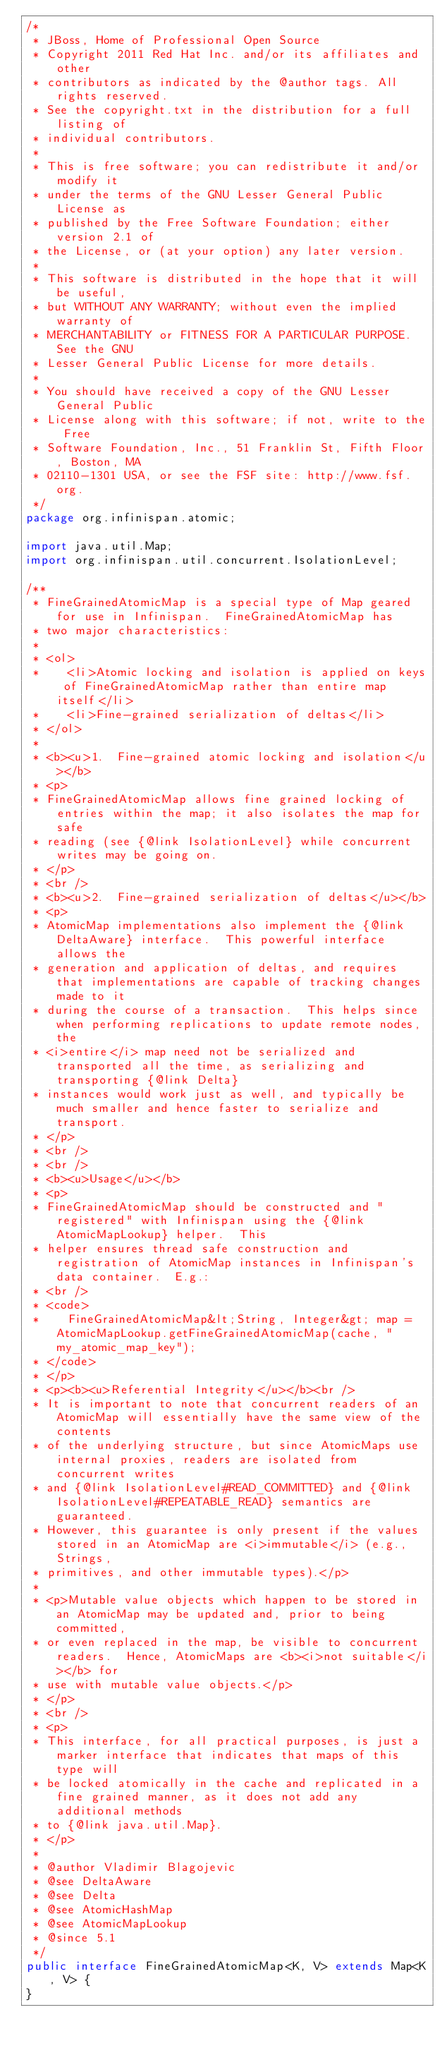<code> <loc_0><loc_0><loc_500><loc_500><_Java_>/*
 * JBoss, Home of Professional Open Source
 * Copyright 2011 Red Hat Inc. and/or its affiliates and other
 * contributors as indicated by the @author tags. All rights reserved.
 * See the copyright.txt in the distribution for a full listing of
 * individual contributors.
 *
 * This is free software; you can redistribute it and/or modify it
 * under the terms of the GNU Lesser General Public License as
 * published by the Free Software Foundation; either version 2.1 of
 * the License, or (at your option) any later version.
 *
 * This software is distributed in the hope that it will be useful,
 * but WITHOUT ANY WARRANTY; without even the implied warranty of
 * MERCHANTABILITY or FITNESS FOR A PARTICULAR PURPOSE. See the GNU
 * Lesser General Public License for more details.
 *
 * You should have received a copy of the GNU Lesser General Public
 * License along with this software; if not, write to the Free
 * Software Foundation, Inc., 51 Franklin St, Fifth Floor, Boston, MA
 * 02110-1301 USA, or see the FSF site: http://www.fsf.org.
 */
package org.infinispan.atomic;

import java.util.Map;
import org.infinispan.util.concurrent.IsolationLevel;

/**
 * FineGrainedAtomicMap is a special type of Map geared for use in Infinispan.  FineGrainedAtomicMap has 
 * two major characteristics:
 *
 * <ol>
 *    <li>Atomic locking and isolation is applied on keys of FineGrainedAtomicMap rather than entire map itself</li>
 *    <li>Fine-grained serialization of deltas</li>
 * </ol>
 *
 * <b><u>1.  Fine-grained atomic locking and isolation</u></b>
 * <p>
 * FineGrainedAtomicMap allows fine grained locking of entries within the map; it also isolates the map for safe 
 * reading (see {@link IsolationLevel} while concurrent writes may be going on.
 * </p>
 * <br />
 * <b><u>2.  Fine-grained serialization of deltas</u></b>
 * <p>
 * AtomicMap implementations also implement the {@link DeltaAware} interface.  This powerful interface allows the
 * generation and application of deltas, and requires that implementations are capable of tracking changes made to it
 * during the course of a transaction.  This helps since when performing replications to update remote nodes, the
 * <i>entire</i> map need not be serialized and transported all the time, as serializing and transporting {@link Delta}
 * instances would work just as well, and typically be much smaller and hence faster to serialize and transport.
 * </p>
 * <br />
 * <br />
 * <b><u>Usage</u></b>
 * <p>
 * FineGrainedAtomicMap should be constructed and "registered" with Infinispan using the {@link AtomicMapLookup} helper.  This
 * helper ensures thread safe construction and registration of AtomicMap instances in Infinispan's data container.  E.g.:
 * <br />
 * <code>
 *    FineGrainedAtomicMap&lt;String, Integer&gt; map = AtomicMapLookup.getFineGrainedAtomicMap(cache, "my_atomic_map_key");
 * </code>
 * </p>
 * <p><b><u>Referential Integrity</u></b><br />
 * It is important to note that concurrent readers of an AtomicMap will essentially have the same view of the contents
 * of the underlying structure, but since AtomicMaps use internal proxies, readers are isolated from concurrent writes
 * and {@link IsolationLevel#READ_COMMITTED} and {@link IsolationLevel#REPEATABLE_READ} semantics are guaranteed.
 * However, this guarantee is only present if the values stored in an AtomicMap are <i>immutable</i> (e.g., Strings,
 * primitives, and other immutable types).</p>
 *
 * <p>Mutable value objects which happen to be stored in an AtomicMap may be updated and, prior to being committed,
 * or even replaced in the map, be visible to concurrent readers.  Hence, AtomicMaps are <b><i>not suitable</i></b> for
 * use with mutable value objects.</p>
 * </p>
 * <br />
 * <p>
 * This interface, for all practical purposes, is just a marker interface that indicates that maps of this type will
 * be locked atomically in the cache and replicated in a fine grained manner, as it does not add any additional methods
 * to {@link java.util.Map}.
 * </p>
 *
 * @author Vladimir Blagojevic
 * @see DeltaAware
 * @see Delta
 * @see AtomicHashMap
 * @see AtomicMapLookup
 * @since 5.1
 */
public interface FineGrainedAtomicMap<K, V> extends Map<K, V> {
}
</code> 